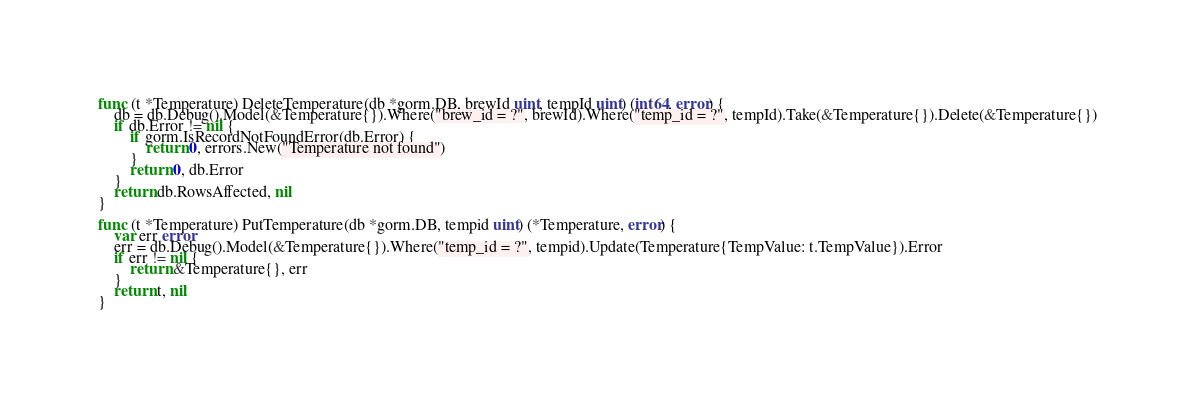Convert code to text. <code><loc_0><loc_0><loc_500><loc_500><_Go_>func (t *Temperature) DeleteTemperature(db *gorm.DB, brewId uint, tempId uint) (int64, error) {
	db = db.Debug().Model(&Temperature{}).Where("brew_id = ?", brewId).Where("temp_id = ?", tempId).Take(&Temperature{}).Delete(&Temperature{})
	if db.Error != nil {
		if gorm.IsRecordNotFoundError(db.Error) {
			return 0, errors.New("Temperature not found")
		}
		return 0, db.Error
	}
	return db.RowsAffected, nil
}

func (t *Temperature) PutTemperature(db *gorm.DB, tempid uint) (*Temperature, error) {
	var err error
	err = db.Debug().Model(&Temperature{}).Where("temp_id = ?", tempid).Update(Temperature{TempValue: t.TempValue}).Error
	if err != nil {
		return &Temperature{}, err
	}
	return t, nil
}</code> 